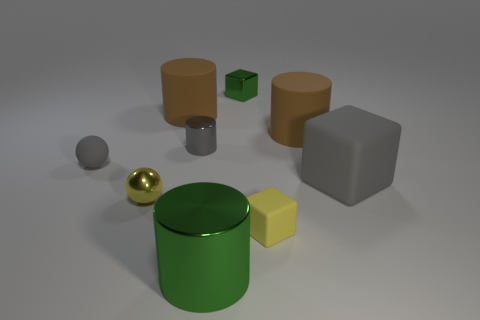Add 1 small red cylinders. How many objects exist? 10 Subtract all balls. How many objects are left? 7 Subtract all green cubes. Subtract all small yellow matte blocks. How many objects are left? 7 Add 7 yellow cubes. How many yellow cubes are left? 8 Add 1 large blue rubber cylinders. How many large blue rubber cylinders exist? 1 Subtract 0 blue cylinders. How many objects are left? 9 